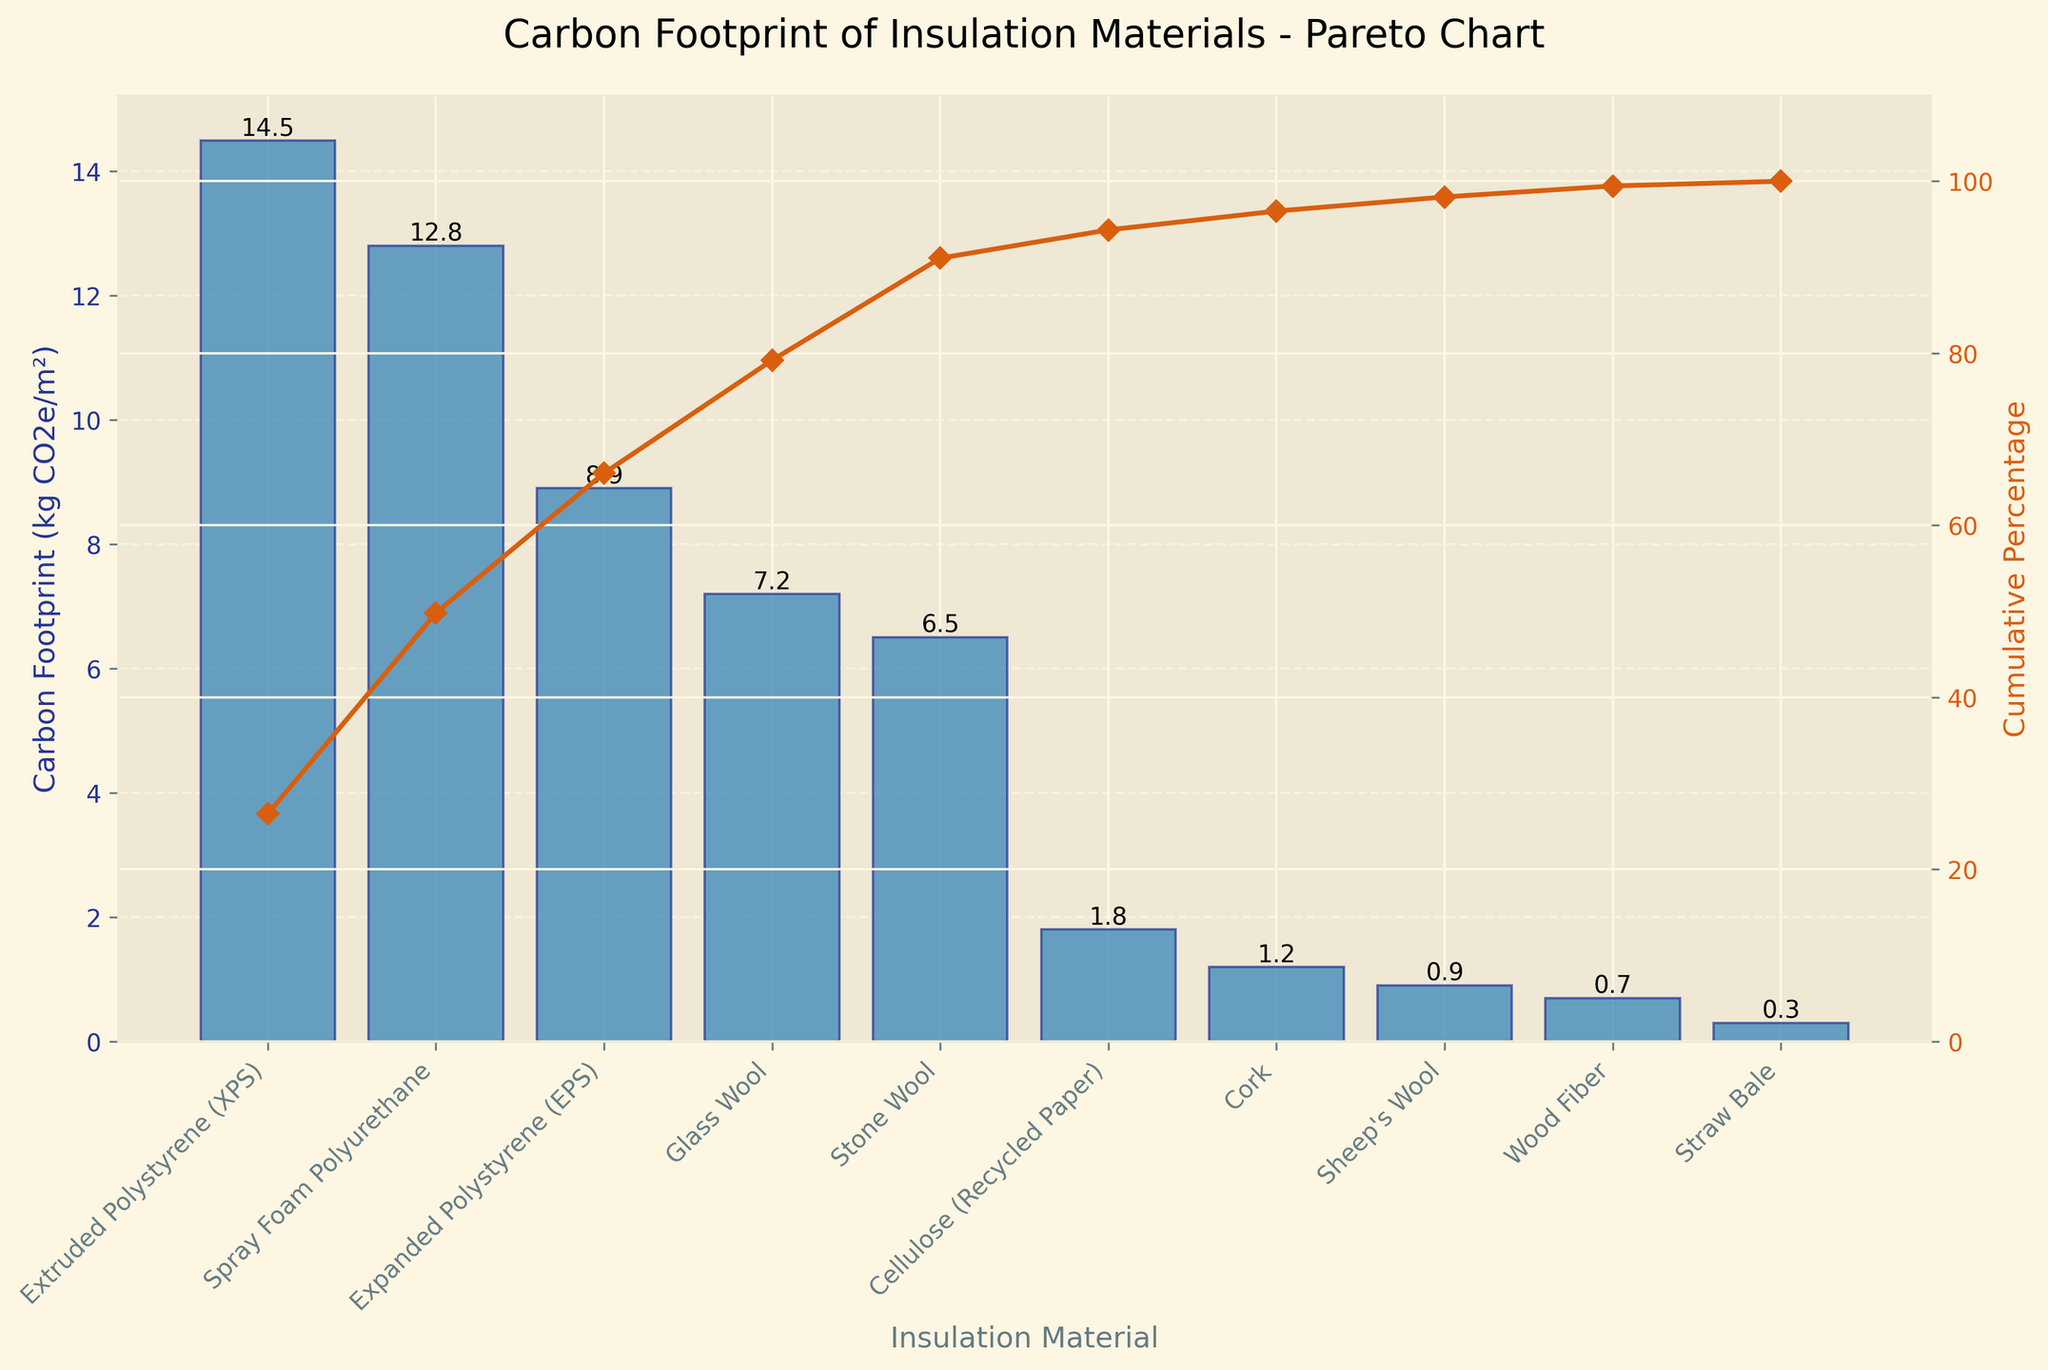What is the title of the chart? The title is displayed at the top of the chart and reads "Carbon Footprint of Insulation Materials - Pareto Chart."
Answer: Carbon Footprint of Insulation Materials - Pareto Chart Which insulation material has the highest carbon footprint? The bars in the chart represent the carbon footprint, with the tallest bar indicating the highest value. The tallest bar corresponds to Extruded Polystyrene (XPS).
Answer: Extruded Polystyrene (XPS) What is the carbon footprint of Sheep's Wool? Locate the bar labeled Sheep's Wool on the x-axis and check the height of the bar, which represents the carbon footprint. The height of the bar for Sheep’s Wool is 0.9 kg CO2e/m².
Answer: 0.9 kg CO2e/m² How many insulation materials have a carbon footprint of less than 5 kg CO2e/m²? Identify all bars that have heights less than the 5 kg CO2e/m² mark. These materials are Cellulose (Recycled Paper), Cork, Sheep's Wool, Wood Fiber, and Straw Bale. There are 5 materials.
Answer: 5 What is the cumulative percentage of carbon footprint when considering the top three materials? The cumulative percentage line indicates how much each successive group adds up. The cumulative percentage for Extruded Polystyrene (XPS), Spray Foam Polyurethane, and Expanded Polystyrene (EPS) is approximately 40%.
Answer: 40% Which material contributes the least to the carbon footprint? The shortest bar on the chart represents the material with the least carbon footprint. The shortest bar is for Straw Bale.
Answer: Straw Bale What's the difference in carbon footprint between Glass Wool and Stone Wool? Find the bars labeled Glass Wool and Stone Wool and note their heights, which are 7.2 and 6.5 kg CO2e/m² respectively. Subtract the smaller value from the larger one: 7.2 - 6.5 = 0.7 kg CO2e/m².
Answer: 0.7 kg CO2e/m² Which material crosses the 60% cumulative percentage mark in the Pareto chart? Look at the cumulative percentage line and find where it crosses the 60% mark. This occurs at Stone Wool.
Answer: Stone Wool What percentage of the total carbon footprint is contributed by the top five materials? Add the cumulative percentages from the first five materials (Extruded Polystyrene (XPS), Spray Foam Polyurethane, Expanded Polystyrene (EPS), Glass Wool, and Stone Wool): approximately 70%. This is confirmed by the cumulative line.
Answer: 70% What is the average carbon footprint of all the listed insulation materials? Add up all the individual carbon footprints: 14.5 + 12.8 + 8.9 + 7.2 + 6.5 + 1.8 + 1.2 + 0.9 + 0.7 + 0.3 = 54.8. Divide this sum by the number of materials, which is 10: 54.8 / 10 = 5.48 kg CO2e/m².
Answer: 5.48 kg CO2e/m² 